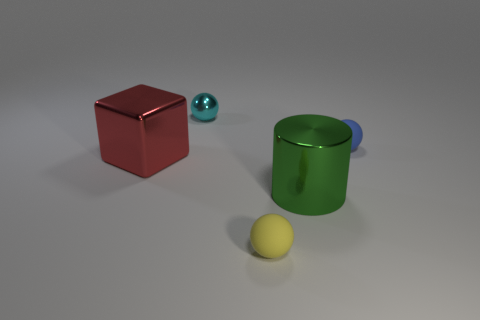What number of small cyan objects have the same shape as the small yellow rubber thing?
Offer a terse response. 1. How many things are big red objects that are to the left of the tiny yellow thing or things to the right of the red shiny block?
Give a very brief answer. 5. Are there any other things that have the same shape as the large green metallic object?
Keep it short and to the point. No. How many yellow rubber objects are there?
Make the answer very short. 1. Are there any blue shiny cubes that have the same size as the blue matte thing?
Offer a terse response. No. Do the cyan thing and the thing that is in front of the shiny cylinder have the same material?
Your answer should be very brief. No. What is the material of the sphere that is in front of the red metallic thing?
Make the answer very short. Rubber. What is the size of the cyan object?
Make the answer very short. Small. There is a shiny object that is on the left side of the cyan thing; does it have the same size as the metallic thing that is to the right of the cyan object?
Ensure brevity in your answer.  Yes. What size is the other rubber thing that is the same shape as the yellow rubber object?
Provide a succinct answer. Small. 